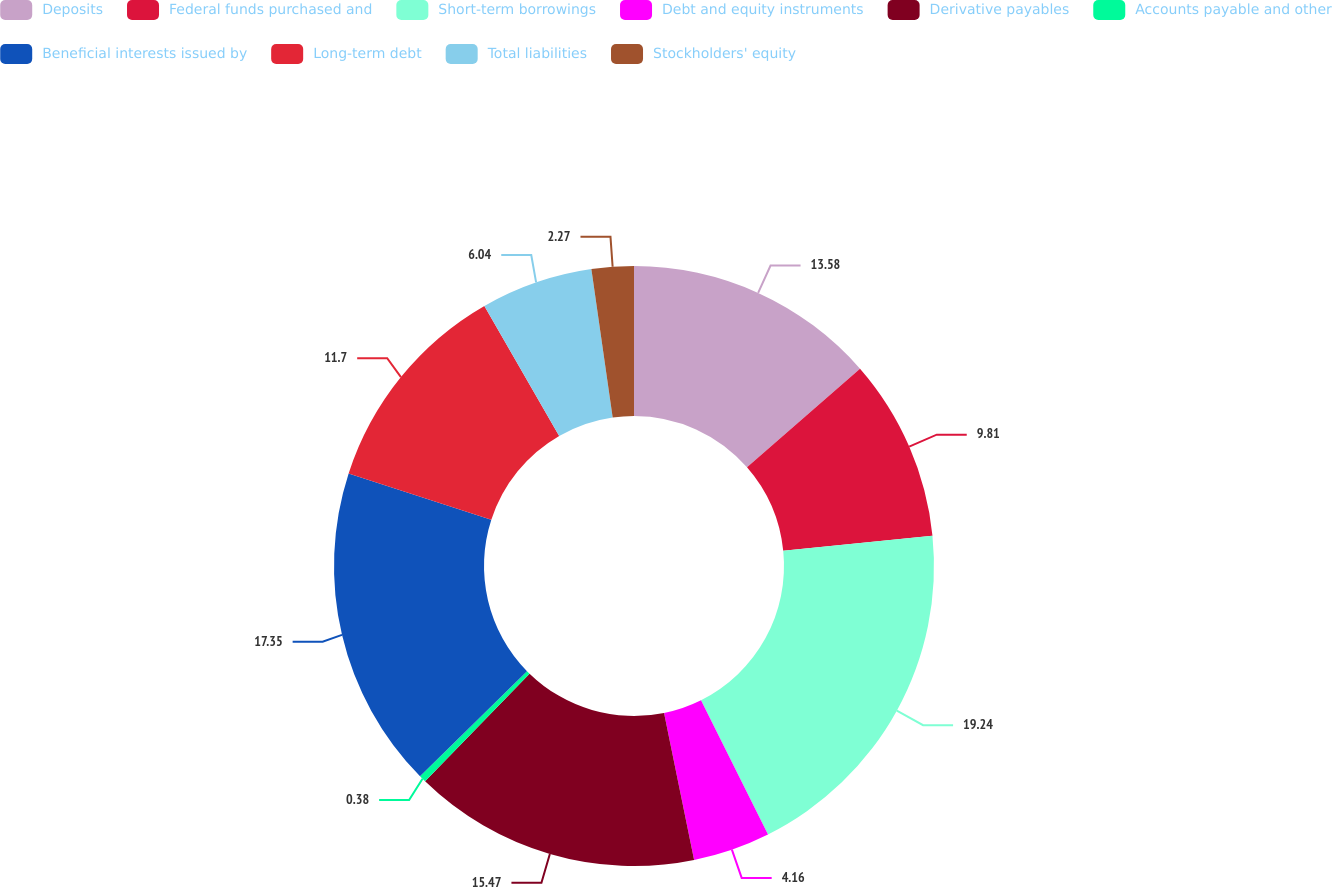<chart> <loc_0><loc_0><loc_500><loc_500><pie_chart><fcel>Deposits<fcel>Federal funds purchased and<fcel>Short-term borrowings<fcel>Debt and equity instruments<fcel>Derivative payables<fcel>Accounts payable and other<fcel>Beneficial interests issued by<fcel>Long-term debt<fcel>Total liabilities<fcel>Stockholders' equity<nl><fcel>13.58%<fcel>9.81%<fcel>19.24%<fcel>4.16%<fcel>15.47%<fcel>0.38%<fcel>17.35%<fcel>11.7%<fcel>6.04%<fcel>2.27%<nl></chart> 